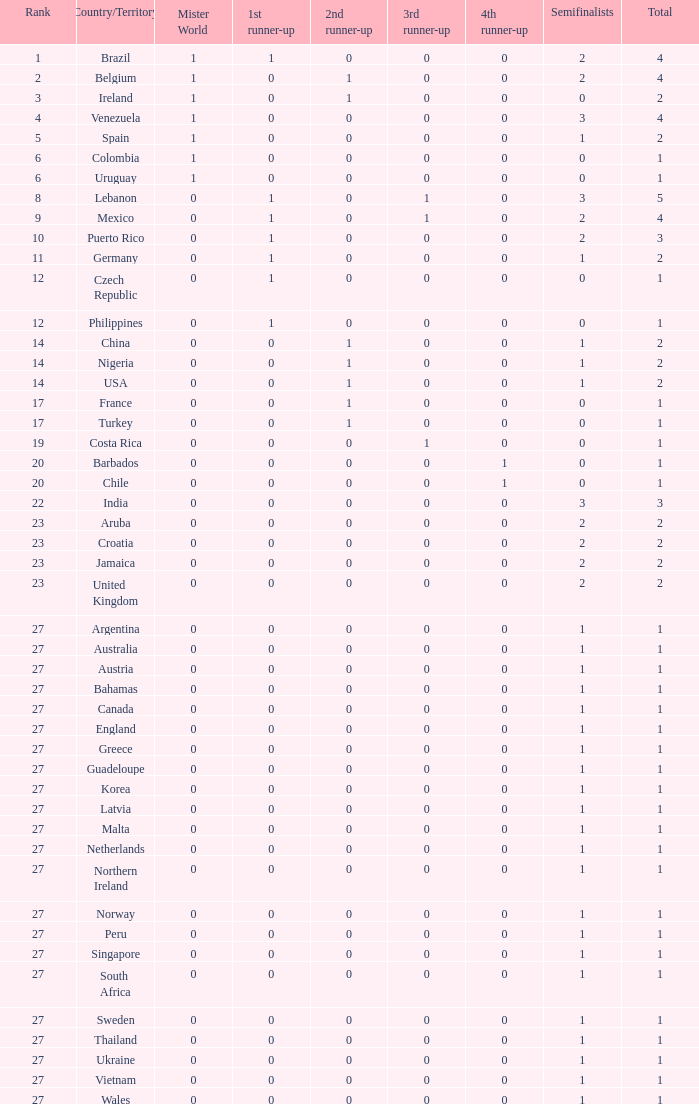What is the tiniest 1st runner up value? 0.0. 